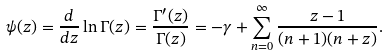<formula> <loc_0><loc_0><loc_500><loc_500>\psi ( z ) = \frac { d } { d z } \ln \Gamma ( z ) = \frac { \Gamma ^ { \prime } ( z ) } { \Gamma ( z ) } = - \gamma + \sum _ { n = 0 } ^ { \infty } \frac { z - 1 } { ( n + 1 ) ( n + z ) } .</formula> 